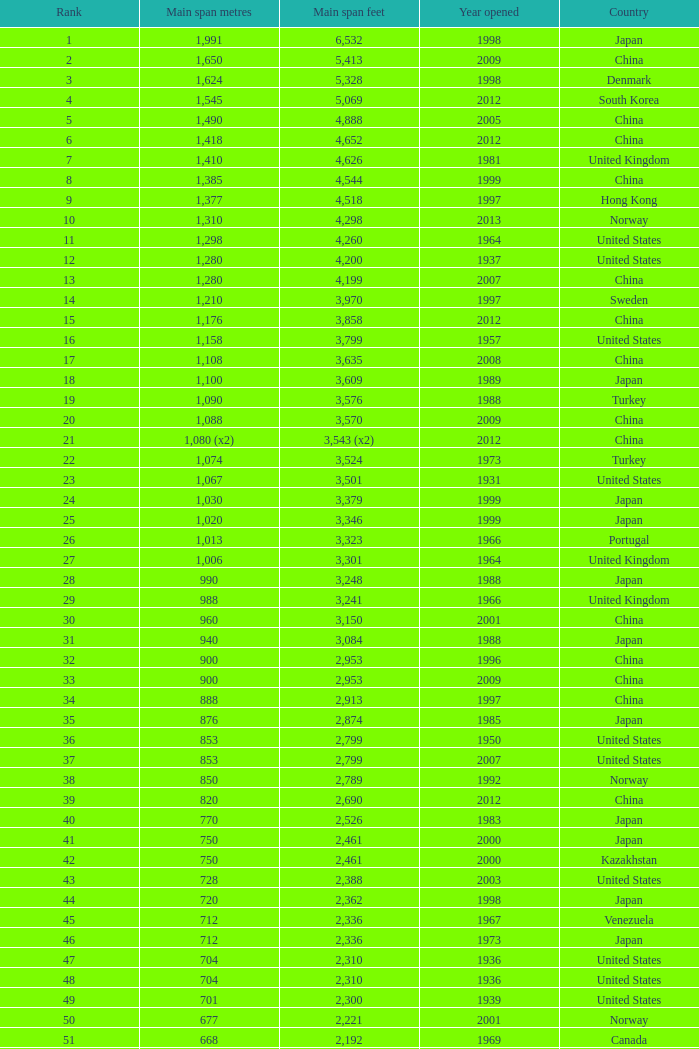What is the maximum ranking from the year beyond 2010 with 430 principal span metres? 94.0. 